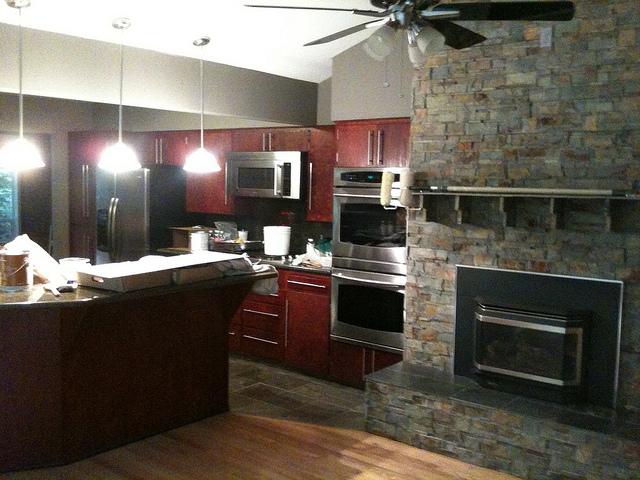What type of oven is in the kitchen?
Short answer required. Electric. Is the kitchen modern?
Answer briefly. Yes. Are the vases indoors or outdoors?
Keep it brief. Indoors. Does this kitchen contain recessed lighting?
Answer briefly. No. 